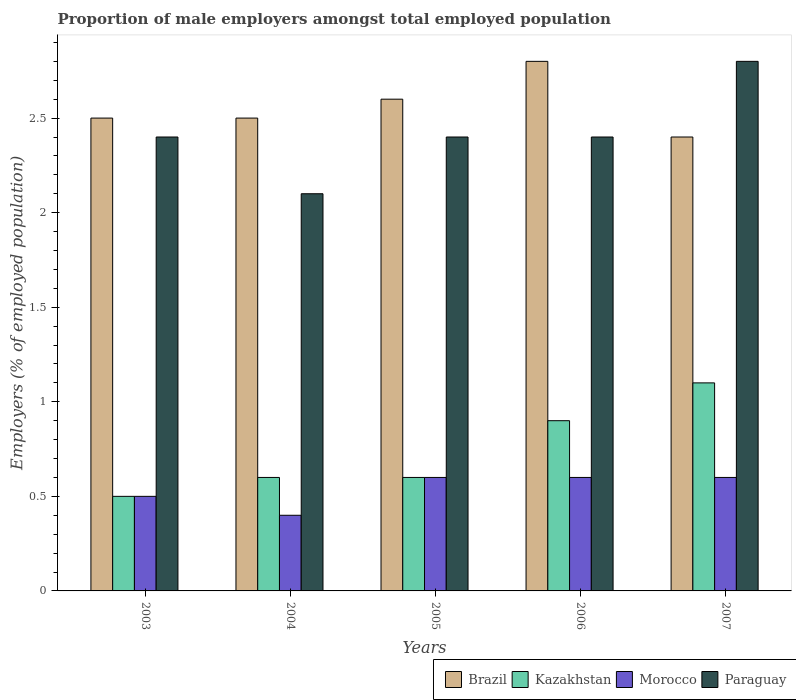How many different coloured bars are there?
Make the answer very short. 4. Are the number of bars per tick equal to the number of legend labels?
Your response must be concise. Yes. Are the number of bars on each tick of the X-axis equal?
Make the answer very short. Yes. How many bars are there on the 1st tick from the right?
Offer a terse response. 4. What is the proportion of male employers in Morocco in 2004?
Give a very brief answer. 0.4. Across all years, what is the maximum proportion of male employers in Kazakhstan?
Your response must be concise. 1.1. Across all years, what is the minimum proportion of male employers in Morocco?
Keep it short and to the point. 0.4. What is the total proportion of male employers in Brazil in the graph?
Your response must be concise. 12.8. What is the difference between the proportion of male employers in Brazil in 2004 and that in 2007?
Give a very brief answer. 0.1. What is the difference between the proportion of male employers in Paraguay in 2007 and the proportion of male employers in Kazakhstan in 2003?
Your answer should be compact. 2.3. What is the average proportion of male employers in Kazakhstan per year?
Ensure brevity in your answer.  0.74. In the year 2004, what is the difference between the proportion of male employers in Morocco and proportion of male employers in Brazil?
Provide a succinct answer. -2.1. In how many years, is the proportion of male employers in Brazil greater than 0.5 %?
Make the answer very short. 5. What is the ratio of the proportion of male employers in Brazil in 2006 to that in 2007?
Give a very brief answer. 1.17. Is the proportion of male employers in Brazil in 2003 less than that in 2004?
Provide a succinct answer. No. What is the difference between the highest and the second highest proportion of male employers in Kazakhstan?
Give a very brief answer. 0.2. What is the difference between the highest and the lowest proportion of male employers in Brazil?
Your response must be concise. 0.4. In how many years, is the proportion of male employers in Kazakhstan greater than the average proportion of male employers in Kazakhstan taken over all years?
Provide a succinct answer. 2. What does the 4th bar from the left in 2005 represents?
Your response must be concise. Paraguay. What does the 1st bar from the right in 2004 represents?
Offer a terse response. Paraguay. How many bars are there?
Offer a very short reply. 20. Are all the bars in the graph horizontal?
Provide a short and direct response. No. What is the difference between two consecutive major ticks on the Y-axis?
Your answer should be compact. 0.5. Where does the legend appear in the graph?
Offer a terse response. Bottom right. How are the legend labels stacked?
Offer a very short reply. Horizontal. What is the title of the graph?
Offer a very short reply. Proportion of male employers amongst total employed population. What is the label or title of the Y-axis?
Provide a succinct answer. Employers (% of employed population). What is the Employers (% of employed population) of Brazil in 2003?
Ensure brevity in your answer.  2.5. What is the Employers (% of employed population) in Paraguay in 2003?
Offer a terse response. 2.4. What is the Employers (% of employed population) of Brazil in 2004?
Provide a succinct answer. 2.5. What is the Employers (% of employed population) of Kazakhstan in 2004?
Give a very brief answer. 0.6. What is the Employers (% of employed population) of Morocco in 2004?
Your answer should be very brief. 0.4. What is the Employers (% of employed population) of Paraguay in 2004?
Ensure brevity in your answer.  2.1. What is the Employers (% of employed population) of Brazil in 2005?
Your response must be concise. 2.6. What is the Employers (% of employed population) in Kazakhstan in 2005?
Your answer should be very brief. 0.6. What is the Employers (% of employed population) of Morocco in 2005?
Ensure brevity in your answer.  0.6. What is the Employers (% of employed population) of Paraguay in 2005?
Offer a very short reply. 2.4. What is the Employers (% of employed population) in Brazil in 2006?
Give a very brief answer. 2.8. What is the Employers (% of employed population) of Kazakhstan in 2006?
Provide a short and direct response. 0.9. What is the Employers (% of employed population) of Morocco in 2006?
Give a very brief answer. 0.6. What is the Employers (% of employed population) of Paraguay in 2006?
Offer a very short reply. 2.4. What is the Employers (% of employed population) of Brazil in 2007?
Provide a succinct answer. 2.4. What is the Employers (% of employed population) in Kazakhstan in 2007?
Your response must be concise. 1.1. What is the Employers (% of employed population) in Morocco in 2007?
Provide a short and direct response. 0.6. What is the Employers (% of employed population) of Paraguay in 2007?
Make the answer very short. 2.8. Across all years, what is the maximum Employers (% of employed population) in Brazil?
Make the answer very short. 2.8. Across all years, what is the maximum Employers (% of employed population) in Kazakhstan?
Give a very brief answer. 1.1. Across all years, what is the maximum Employers (% of employed population) of Morocco?
Your answer should be compact. 0.6. Across all years, what is the maximum Employers (% of employed population) of Paraguay?
Your response must be concise. 2.8. Across all years, what is the minimum Employers (% of employed population) of Brazil?
Offer a very short reply. 2.4. Across all years, what is the minimum Employers (% of employed population) in Kazakhstan?
Provide a succinct answer. 0.5. Across all years, what is the minimum Employers (% of employed population) of Morocco?
Provide a short and direct response. 0.4. Across all years, what is the minimum Employers (% of employed population) of Paraguay?
Make the answer very short. 2.1. What is the total Employers (% of employed population) of Morocco in the graph?
Your response must be concise. 2.7. What is the difference between the Employers (% of employed population) of Brazil in 2003 and that in 2004?
Provide a short and direct response. 0. What is the difference between the Employers (% of employed population) in Kazakhstan in 2003 and that in 2004?
Ensure brevity in your answer.  -0.1. What is the difference between the Employers (% of employed population) in Morocco in 2003 and that in 2004?
Offer a terse response. 0.1. What is the difference between the Employers (% of employed population) of Paraguay in 2003 and that in 2004?
Give a very brief answer. 0.3. What is the difference between the Employers (% of employed population) in Morocco in 2003 and that in 2005?
Provide a short and direct response. -0.1. What is the difference between the Employers (% of employed population) in Kazakhstan in 2003 and that in 2006?
Your response must be concise. -0.4. What is the difference between the Employers (% of employed population) in Morocco in 2003 and that in 2006?
Provide a short and direct response. -0.1. What is the difference between the Employers (% of employed population) in Kazakhstan in 2003 and that in 2007?
Offer a very short reply. -0.6. What is the difference between the Employers (% of employed population) of Paraguay in 2003 and that in 2007?
Make the answer very short. -0.4. What is the difference between the Employers (% of employed population) in Paraguay in 2004 and that in 2005?
Your answer should be very brief. -0.3. What is the difference between the Employers (% of employed population) of Kazakhstan in 2004 and that in 2006?
Keep it short and to the point. -0.3. What is the difference between the Employers (% of employed population) of Brazil in 2004 and that in 2007?
Provide a succinct answer. 0.1. What is the difference between the Employers (% of employed population) in Kazakhstan in 2004 and that in 2007?
Give a very brief answer. -0.5. What is the difference between the Employers (% of employed population) in Morocco in 2004 and that in 2007?
Offer a terse response. -0.2. What is the difference between the Employers (% of employed population) of Brazil in 2005 and that in 2006?
Provide a succinct answer. -0.2. What is the difference between the Employers (% of employed population) in Brazil in 2005 and that in 2007?
Your response must be concise. 0.2. What is the difference between the Employers (% of employed population) in Kazakhstan in 2006 and that in 2007?
Your answer should be compact. -0.2. What is the difference between the Employers (% of employed population) in Morocco in 2006 and that in 2007?
Ensure brevity in your answer.  0. What is the difference between the Employers (% of employed population) in Kazakhstan in 2003 and the Employers (% of employed population) in Morocco in 2004?
Your response must be concise. 0.1. What is the difference between the Employers (% of employed population) in Brazil in 2003 and the Employers (% of employed population) in Kazakhstan in 2005?
Offer a terse response. 1.9. What is the difference between the Employers (% of employed population) of Brazil in 2003 and the Employers (% of employed population) of Morocco in 2005?
Your response must be concise. 1.9. What is the difference between the Employers (% of employed population) in Brazil in 2003 and the Employers (% of employed population) in Kazakhstan in 2006?
Offer a terse response. 1.6. What is the difference between the Employers (% of employed population) of Brazil in 2003 and the Employers (% of employed population) of Paraguay in 2006?
Keep it short and to the point. 0.1. What is the difference between the Employers (% of employed population) in Kazakhstan in 2003 and the Employers (% of employed population) in Paraguay in 2006?
Keep it short and to the point. -1.9. What is the difference between the Employers (% of employed population) in Kazakhstan in 2003 and the Employers (% of employed population) in Paraguay in 2007?
Offer a very short reply. -2.3. What is the difference between the Employers (% of employed population) of Morocco in 2003 and the Employers (% of employed population) of Paraguay in 2007?
Keep it short and to the point. -2.3. What is the difference between the Employers (% of employed population) of Brazil in 2004 and the Employers (% of employed population) of Kazakhstan in 2005?
Offer a terse response. 1.9. What is the difference between the Employers (% of employed population) of Brazil in 2004 and the Employers (% of employed population) of Morocco in 2005?
Offer a very short reply. 1.9. What is the difference between the Employers (% of employed population) in Morocco in 2004 and the Employers (% of employed population) in Paraguay in 2005?
Your answer should be compact. -2. What is the difference between the Employers (% of employed population) of Kazakhstan in 2004 and the Employers (% of employed population) of Morocco in 2006?
Keep it short and to the point. 0. What is the difference between the Employers (% of employed population) in Morocco in 2004 and the Employers (% of employed population) in Paraguay in 2006?
Offer a terse response. -2. What is the difference between the Employers (% of employed population) in Brazil in 2004 and the Employers (% of employed population) in Paraguay in 2007?
Your answer should be very brief. -0.3. What is the difference between the Employers (% of employed population) in Kazakhstan in 2004 and the Employers (% of employed population) in Morocco in 2007?
Offer a terse response. 0. What is the difference between the Employers (% of employed population) in Morocco in 2004 and the Employers (% of employed population) in Paraguay in 2007?
Keep it short and to the point. -2.4. What is the difference between the Employers (% of employed population) in Brazil in 2005 and the Employers (% of employed population) in Kazakhstan in 2006?
Your answer should be very brief. 1.7. What is the difference between the Employers (% of employed population) in Brazil in 2005 and the Employers (% of employed population) in Paraguay in 2006?
Offer a terse response. 0.2. What is the difference between the Employers (% of employed population) in Kazakhstan in 2005 and the Employers (% of employed population) in Morocco in 2006?
Your response must be concise. 0. What is the difference between the Employers (% of employed population) of Kazakhstan in 2005 and the Employers (% of employed population) of Paraguay in 2006?
Give a very brief answer. -1.8. What is the difference between the Employers (% of employed population) of Brazil in 2005 and the Employers (% of employed population) of Kazakhstan in 2007?
Provide a short and direct response. 1.5. What is the difference between the Employers (% of employed population) of Kazakhstan in 2005 and the Employers (% of employed population) of Morocco in 2007?
Make the answer very short. 0. What is the difference between the Employers (% of employed population) in Kazakhstan in 2005 and the Employers (% of employed population) in Paraguay in 2007?
Provide a short and direct response. -2.2. What is the difference between the Employers (% of employed population) of Morocco in 2005 and the Employers (% of employed population) of Paraguay in 2007?
Provide a succinct answer. -2.2. What is the difference between the Employers (% of employed population) in Brazil in 2006 and the Employers (% of employed population) in Kazakhstan in 2007?
Make the answer very short. 1.7. What is the difference between the Employers (% of employed population) of Brazil in 2006 and the Employers (% of employed population) of Morocco in 2007?
Offer a terse response. 2.2. What is the difference between the Employers (% of employed population) in Brazil in 2006 and the Employers (% of employed population) in Paraguay in 2007?
Your answer should be compact. 0. What is the difference between the Employers (% of employed population) of Kazakhstan in 2006 and the Employers (% of employed population) of Morocco in 2007?
Provide a short and direct response. 0.3. What is the difference between the Employers (% of employed population) in Morocco in 2006 and the Employers (% of employed population) in Paraguay in 2007?
Keep it short and to the point. -2.2. What is the average Employers (% of employed population) of Brazil per year?
Keep it short and to the point. 2.56. What is the average Employers (% of employed population) in Kazakhstan per year?
Give a very brief answer. 0.74. What is the average Employers (% of employed population) of Morocco per year?
Give a very brief answer. 0.54. What is the average Employers (% of employed population) of Paraguay per year?
Your response must be concise. 2.42. In the year 2003, what is the difference between the Employers (% of employed population) in Brazil and Employers (% of employed population) in Kazakhstan?
Your answer should be very brief. 2. In the year 2003, what is the difference between the Employers (% of employed population) of Brazil and Employers (% of employed population) of Paraguay?
Your answer should be very brief. 0.1. In the year 2003, what is the difference between the Employers (% of employed population) of Kazakhstan and Employers (% of employed population) of Paraguay?
Provide a short and direct response. -1.9. In the year 2003, what is the difference between the Employers (% of employed population) in Morocco and Employers (% of employed population) in Paraguay?
Provide a succinct answer. -1.9. In the year 2004, what is the difference between the Employers (% of employed population) of Brazil and Employers (% of employed population) of Kazakhstan?
Your answer should be very brief. 1.9. In the year 2004, what is the difference between the Employers (% of employed population) in Brazil and Employers (% of employed population) in Paraguay?
Your answer should be compact. 0.4. In the year 2004, what is the difference between the Employers (% of employed population) of Kazakhstan and Employers (% of employed population) of Morocco?
Offer a terse response. 0.2. In the year 2004, what is the difference between the Employers (% of employed population) in Kazakhstan and Employers (% of employed population) in Paraguay?
Your answer should be compact. -1.5. In the year 2005, what is the difference between the Employers (% of employed population) in Brazil and Employers (% of employed population) in Paraguay?
Give a very brief answer. 0.2. In the year 2005, what is the difference between the Employers (% of employed population) in Kazakhstan and Employers (% of employed population) in Morocco?
Your response must be concise. 0. In the year 2006, what is the difference between the Employers (% of employed population) of Brazil and Employers (% of employed population) of Kazakhstan?
Provide a short and direct response. 1.9. In the year 2006, what is the difference between the Employers (% of employed population) in Brazil and Employers (% of employed population) in Morocco?
Keep it short and to the point. 2.2. In the year 2006, what is the difference between the Employers (% of employed population) in Morocco and Employers (% of employed population) in Paraguay?
Ensure brevity in your answer.  -1.8. In the year 2007, what is the difference between the Employers (% of employed population) of Brazil and Employers (% of employed population) of Kazakhstan?
Your answer should be very brief. 1.3. In the year 2007, what is the difference between the Employers (% of employed population) in Brazil and Employers (% of employed population) in Morocco?
Your answer should be compact. 1.8. In the year 2007, what is the difference between the Employers (% of employed population) in Morocco and Employers (% of employed population) in Paraguay?
Provide a short and direct response. -2.2. What is the ratio of the Employers (% of employed population) in Brazil in 2003 to that in 2004?
Provide a succinct answer. 1. What is the ratio of the Employers (% of employed population) in Kazakhstan in 2003 to that in 2004?
Your response must be concise. 0.83. What is the ratio of the Employers (% of employed population) of Morocco in 2003 to that in 2004?
Your answer should be very brief. 1.25. What is the ratio of the Employers (% of employed population) in Brazil in 2003 to that in 2005?
Make the answer very short. 0.96. What is the ratio of the Employers (% of employed population) of Kazakhstan in 2003 to that in 2005?
Ensure brevity in your answer.  0.83. What is the ratio of the Employers (% of employed population) in Brazil in 2003 to that in 2006?
Your response must be concise. 0.89. What is the ratio of the Employers (% of employed population) of Kazakhstan in 2003 to that in 2006?
Your answer should be very brief. 0.56. What is the ratio of the Employers (% of employed population) of Brazil in 2003 to that in 2007?
Make the answer very short. 1.04. What is the ratio of the Employers (% of employed population) of Kazakhstan in 2003 to that in 2007?
Your answer should be very brief. 0.45. What is the ratio of the Employers (% of employed population) of Morocco in 2003 to that in 2007?
Keep it short and to the point. 0.83. What is the ratio of the Employers (% of employed population) of Brazil in 2004 to that in 2005?
Your response must be concise. 0.96. What is the ratio of the Employers (% of employed population) in Paraguay in 2004 to that in 2005?
Keep it short and to the point. 0.88. What is the ratio of the Employers (% of employed population) in Brazil in 2004 to that in 2006?
Keep it short and to the point. 0.89. What is the ratio of the Employers (% of employed population) of Brazil in 2004 to that in 2007?
Keep it short and to the point. 1.04. What is the ratio of the Employers (% of employed population) of Kazakhstan in 2004 to that in 2007?
Give a very brief answer. 0.55. What is the ratio of the Employers (% of employed population) of Morocco in 2004 to that in 2007?
Provide a succinct answer. 0.67. What is the ratio of the Employers (% of employed population) of Paraguay in 2004 to that in 2007?
Offer a very short reply. 0.75. What is the ratio of the Employers (% of employed population) in Morocco in 2005 to that in 2006?
Offer a terse response. 1. What is the ratio of the Employers (% of employed population) of Paraguay in 2005 to that in 2006?
Offer a very short reply. 1. What is the ratio of the Employers (% of employed population) in Brazil in 2005 to that in 2007?
Your response must be concise. 1.08. What is the ratio of the Employers (% of employed population) in Kazakhstan in 2005 to that in 2007?
Your answer should be very brief. 0.55. What is the ratio of the Employers (% of employed population) in Paraguay in 2005 to that in 2007?
Provide a short and direct response. 0.86. What is the ratio of the Employers (% of employed population) of Brazil in 2006 to that in 2007?
Give a very brief answer. 1.17. What is the ratio of the Employers (% of employed population) in Kazakhstan in 2006 to that in 2007?
Your answer should be compact. 0.82. What is the ratio of the Employers (% of employed population) of Paraguay in 2006 to that in 2007?
Offer a very short reply. 0.86. What is the difference between the highest and the second highest Employers (% of employed population) in Kazakhstan?
Your answer should be compact. 0.2. What is the difference between the highest and the lowest Employers (% of employed population) of Brazil?
Provide a succinct answer. 0.4. What is the difference between the highest and the lowest Employers (% of employed population) of Kazakhstan?
Your answer should be compact. 0.6. 